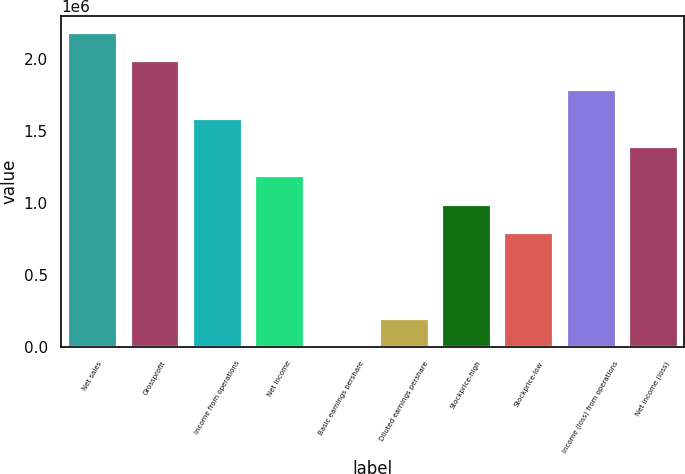Convert chart. <chart><loc_0><loc_0><loc_500><loc_500><bar_chart><fcel>Net sales<fcel>Grossprofit<fcel>Income from operations<fcel>Net income<fcel>Basic earnings pershare<fcel>Diluted earnings pershare<fcel>Stockprice-high<fcel>Stockprice-low<fcel>Income (loss) from operations<fcel>Net income (loss)<nl><fcel>2.19302e+06<fcel>1.99366e+06<fcel>1.59493e+06<fcel>1.19619e+06<fcel>0.49<fcel>199366<fcel>996829<fcel>797463<fcel>1.79429e+06<fcel>1.39556e+06<nl></chart> 